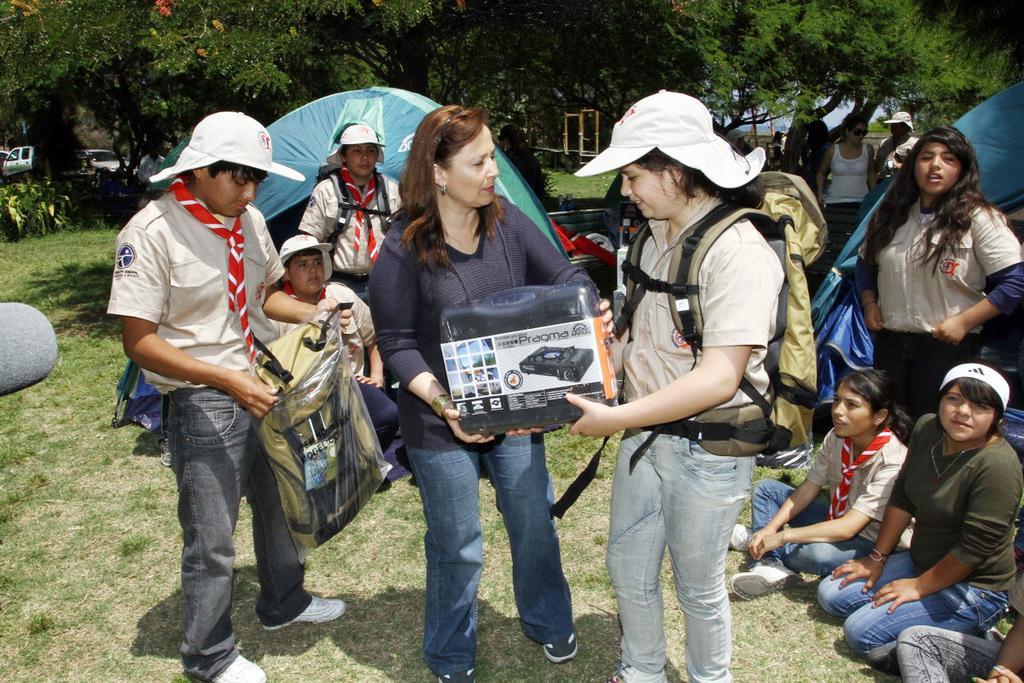How would you summarize this image in a sentence or two? In this image there are group of people, and in the foreground there is one woman who is wearing bag and two of them are holding boxes, and one person is holding bag and some of them are sitting and some of them are standing. And also there are some tents, trees, vehicles and some people. At the bottom there is grass, and on the left side there is one stone and in the background there are some objects. 